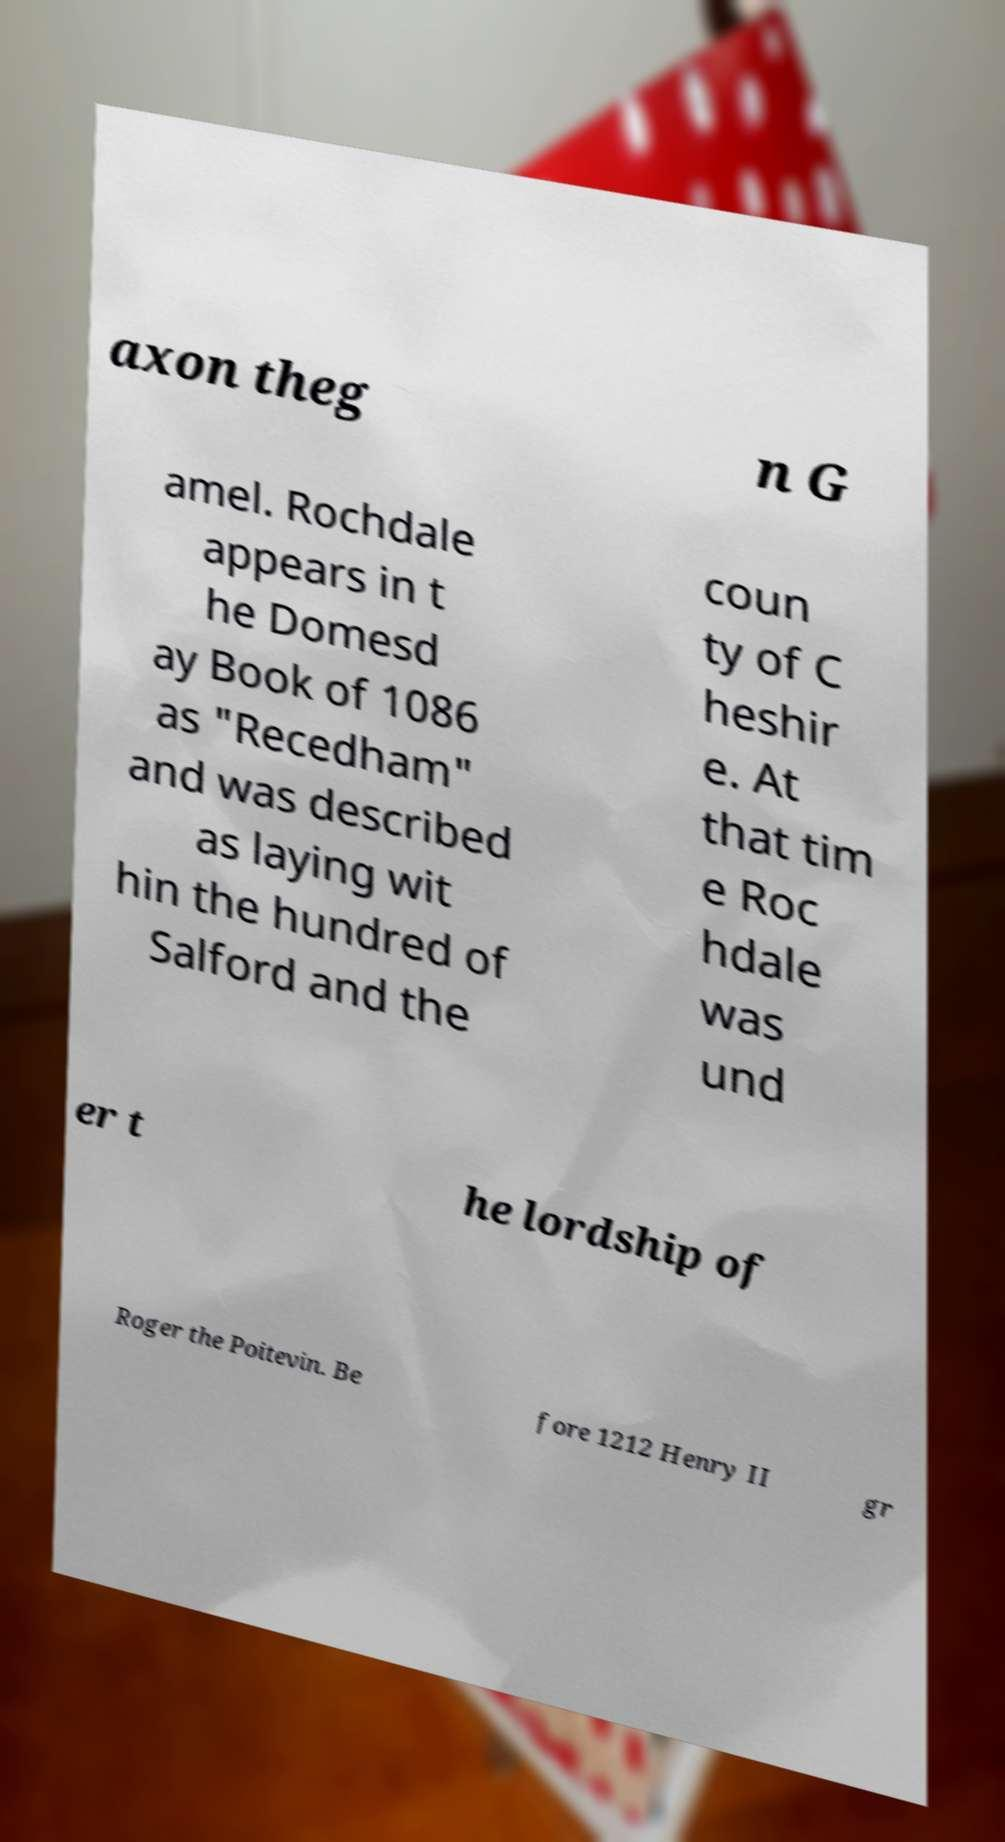There's text embedded in this image that I need extracted. Can you transcribe it verbatim? axon theg n G amel. Rochdale appears in t he Domesd ay Book of 1086 as "Recedham" and was described as laying wit hin the hundred of Salford and the coun ty of C heshir e. At that tim e Roc hdale was und er t he lordship of Roger the Poitevin. Be fore 1212 Henry II gr 